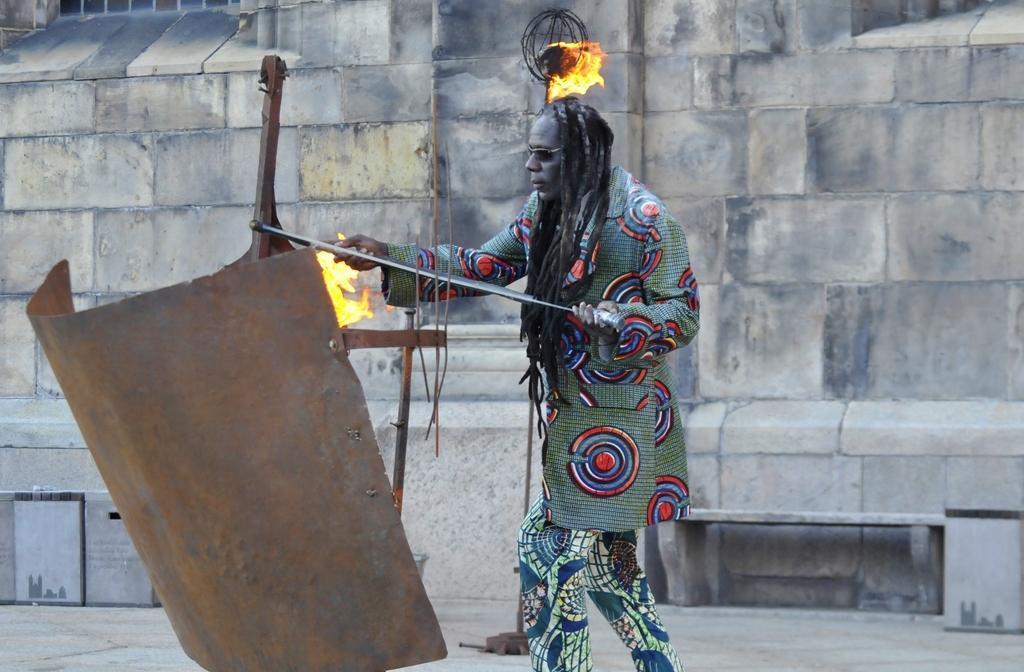How would you summarize this image in a sentence or two? In this picture we can see a person is standing and holding something, on the left side there is a metal sheet, we can see fire in the middle, in the background there is a wall. 